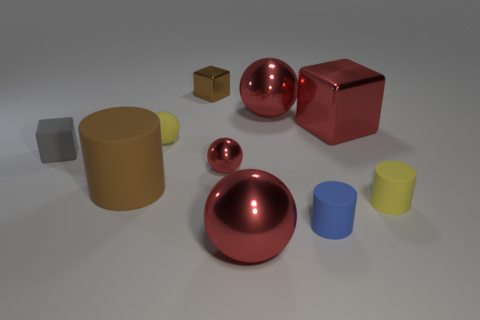Subtract all large matte cylinders. How many cylinders are left? 2 Subtract all cubes. How many objects are left? 7 Subtract 1 cylinders. How many cylinders are left? 2 Subtract all big metal spheres. Subtract all balls. How many objects are left? 4 Add 5 large red metal cubes. How many large red metal cubes are left? 6 Add 1 tiny rubber objects. How many tiny rubber objects exist? 5 Subtract all brown cubes. How many cubes are left? 2 Subtract 0 green cubes. How many objects are left? 10 Subtract all red cylinders. Subtract all red spheres. How many cylinders are left? 3 Subtract all gray cylinders. How many gray blocks are left? 1 